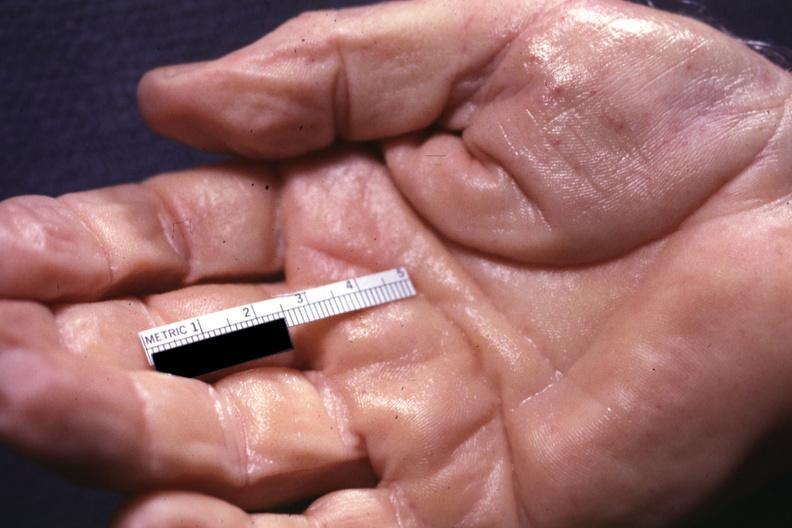does this image show well shown simian crease?
Answer the question using a single word or phrase. This 